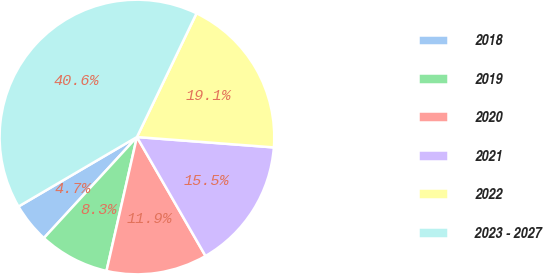Convert chart. <chart><loc_0><loc_0><loc_500><loc_500><pie_chart><fcel>2018<fcel>2019<fcel>2020<fcel>2021<fcel>2022<fcel>2023 - 2027<nl><fcel>4.71%<fcel>8.29%<fcel>11.88%<fcel>15.47%<fcel>19.06%<fcel>40.59%<nl></chart> 